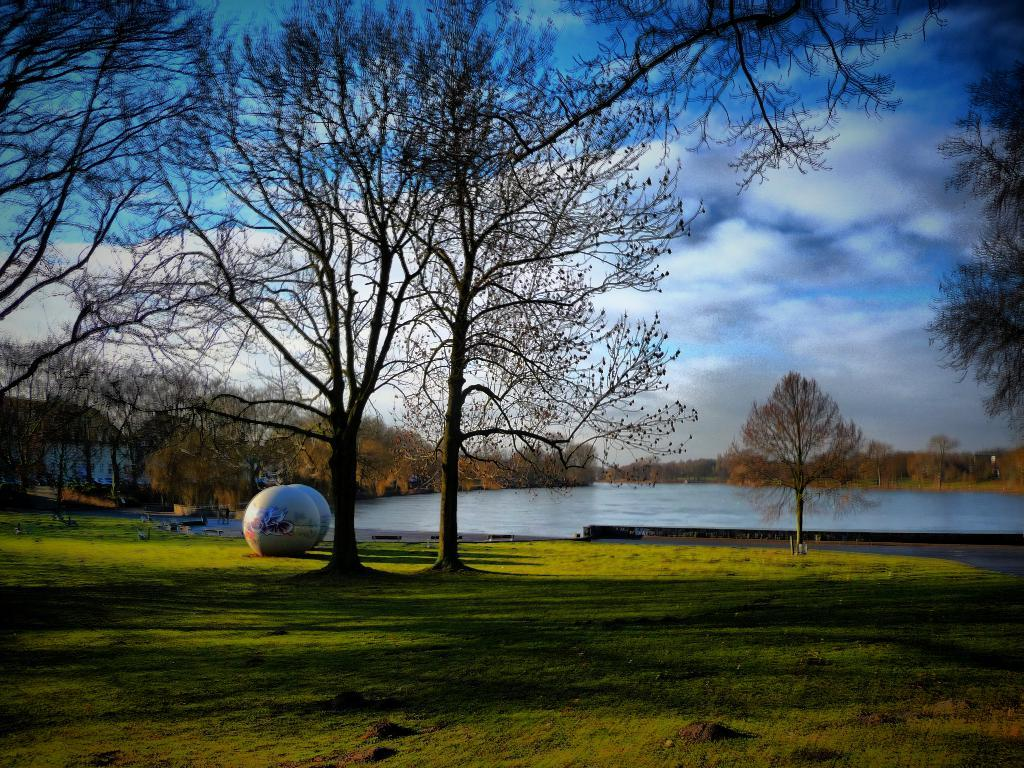What type of scenery is shown in the image? The image depicts a beautiful scenery. What type of vegetation can be seen in the image? There is grass and trees in the image. What natural feature is present in the image? There is a water surface in the image. Can you describe the objects on the left side of one of the trees? On the left side of one of the trees, there are two round objects. How does the cream spread on the grass in the image? There is no cream present in the image, so it cannot spread on the grass. What type of match can be seen in the image? There is no match present in the image. 